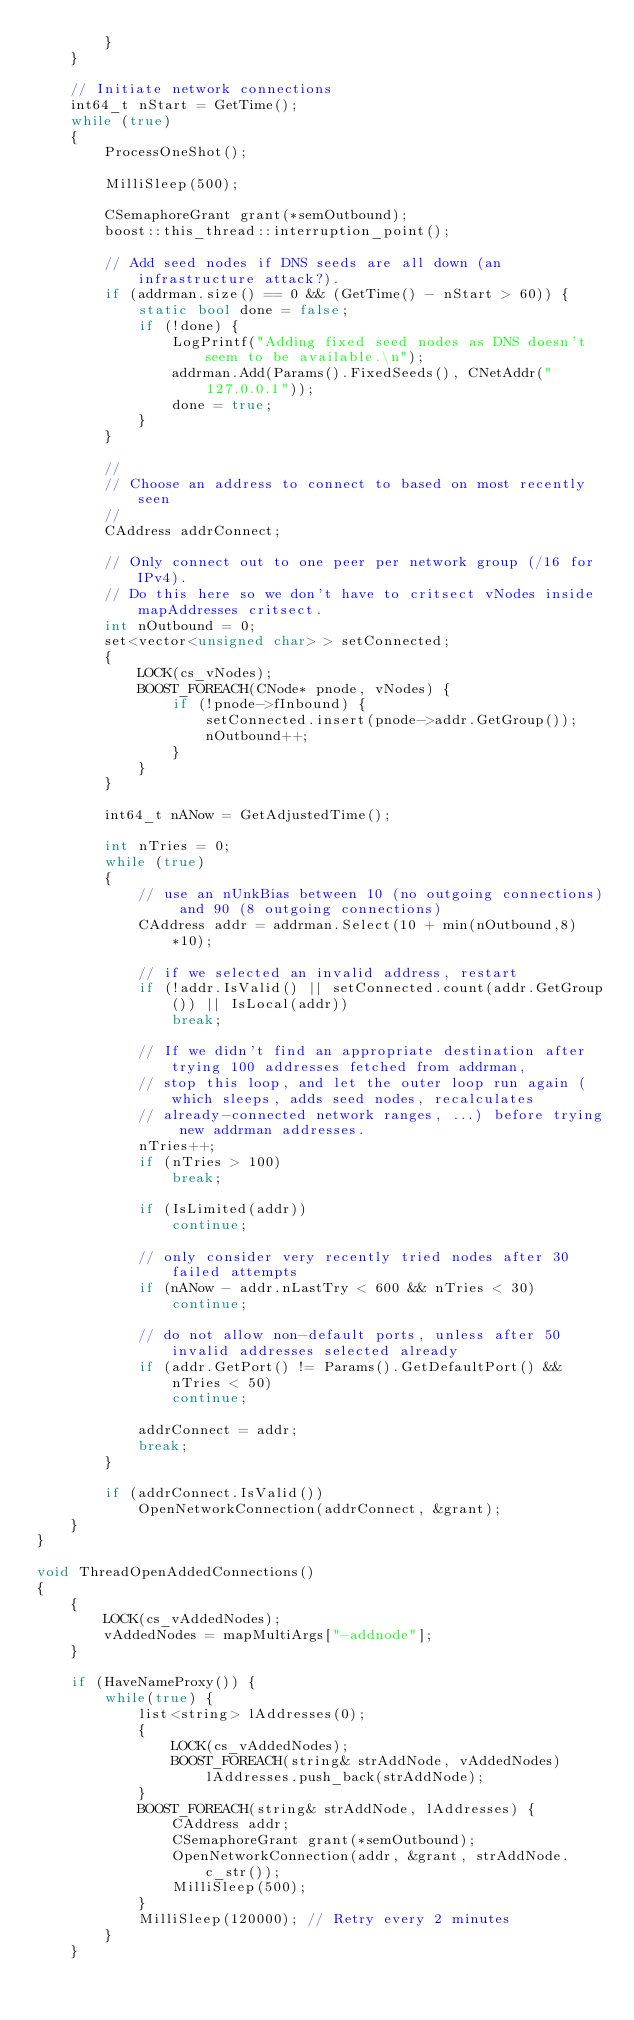Convert code to text. <code><loc_0><loc_0><loc_500><loc_500><_C++_>        }
    }

    // Initiate network connections
    int64_t nStart = GetTime();
    while (true)
    {
        ProcessOneShot();

        MilliSleep(500);

        CSemaphoreGrant grant(*semOutbound);
        boost::this_thread::interruption_point();

        // Add seed nodes if DNS seeds are all down (an infrastructure attack?).
        if (addrman.size() == 0 && (GetTime() - nStart > 60)) {
            static bool done = false;
            if (!done) {
                LogPrintf("Adding fixed seed nodes as DNS doesn't seem to be available.\n");
                addrman.Add(Params().FixedSeeds(), CNetAddr("127.0.0.1"));
                done = true;
            }
        }

        //
        // Choose an address to connect to based on most recently seen
        //
        CAddress addrConnect;

        // Only connect out to one peer per network group (/16 for IPv4).
        // Do this here so we don't have to critsect vNodes inside mapAddresses critsect.
        int nOutbound = 0;
        set<vector<unsigned char> > setConnected;
        {
            LOCK(cs_vNodes);
            BOOST_FOREACH(CNode* pnode, vNodes) {
                if (!pnode->fInbound) {
                    setConnected.insert(pnode->addr.GetGroup());
                    nOutbound++;
                }
            }
        }

        int64_t nANow = GetAdjustedTime();

        int nTries = 0;
        while (true)
        {
            // use an nUnkBias between 10 (no outgoing connections) and 90 (8 outgoing connections)
            CAddress addr = addrman.Select(10 + min(nOutbound,8)*10);

            // if we selected an invalid address, restart
            if (!addr.IsValid() || setConnected.count(addr.GetGroup()) || IsLocal(addr))
                break;

            // If we didn't find an appropriate destination after trying 100 addresses fetched from addrman,
            // stop this loop, and let the outer loop run again (which sleeps, adds seed nodes, recalculates
            // already-connected network ranges, ...) before trying new addrman addresses.
            nTries++;
            if (nTries > 100)
                break;

            if (IsLimited(addr))
                continue;

            // only consider very recently tried nodes after 30 failed attempts
            if (nANow - addr.nLastTry < 600 && nTries < 30)
                continue;

            // do not allow non-default ports, unless after 50 invalid addresses selected already
            if (addr.GetPort() != Params().GetDefaultPort() && nTries < 50)
                continue;

            addrConnect = addr;
            break;
        }

        if (addrConnect.IsValid())
            OpenNetworkConnection(addrConnect, &grant);
    }
}

void ThreadOpenAddedConnections()
{
    {
        LOCK(cs_vAddedNodes);
        vAddedNodes = mapMultiArgs["-addnode"];
    }

    if (HaveNameProxy()) {
        while(true) {
            list<string> lAddresses(0);
            {
                LOCK(cs_vAddedNodes);
                BOOST_FOREACH(string& strAddNode, vAddedNodes)
                    lAddresses.push_back(strAddNode);
            }
            BOOST_FOREACH(string& strAddNode, lAddresses) {
                CAddress addr;
                CSemaphoreGrant grant(*semOutbound);
                OpenNetworkConnection(addr, &grant, strAddNode.c_str());
                MilliSleep(500);
            }
            MilliSleep(120000); // Retry every 2 minutes
        }
    }
</code> 